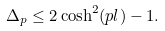<formula> <loc_0><loc_0><loc_500><loc_500>\Delta _ { p } \leq 2 \cosh ^ { 2 } ( p l ) - 1 .</formula> 